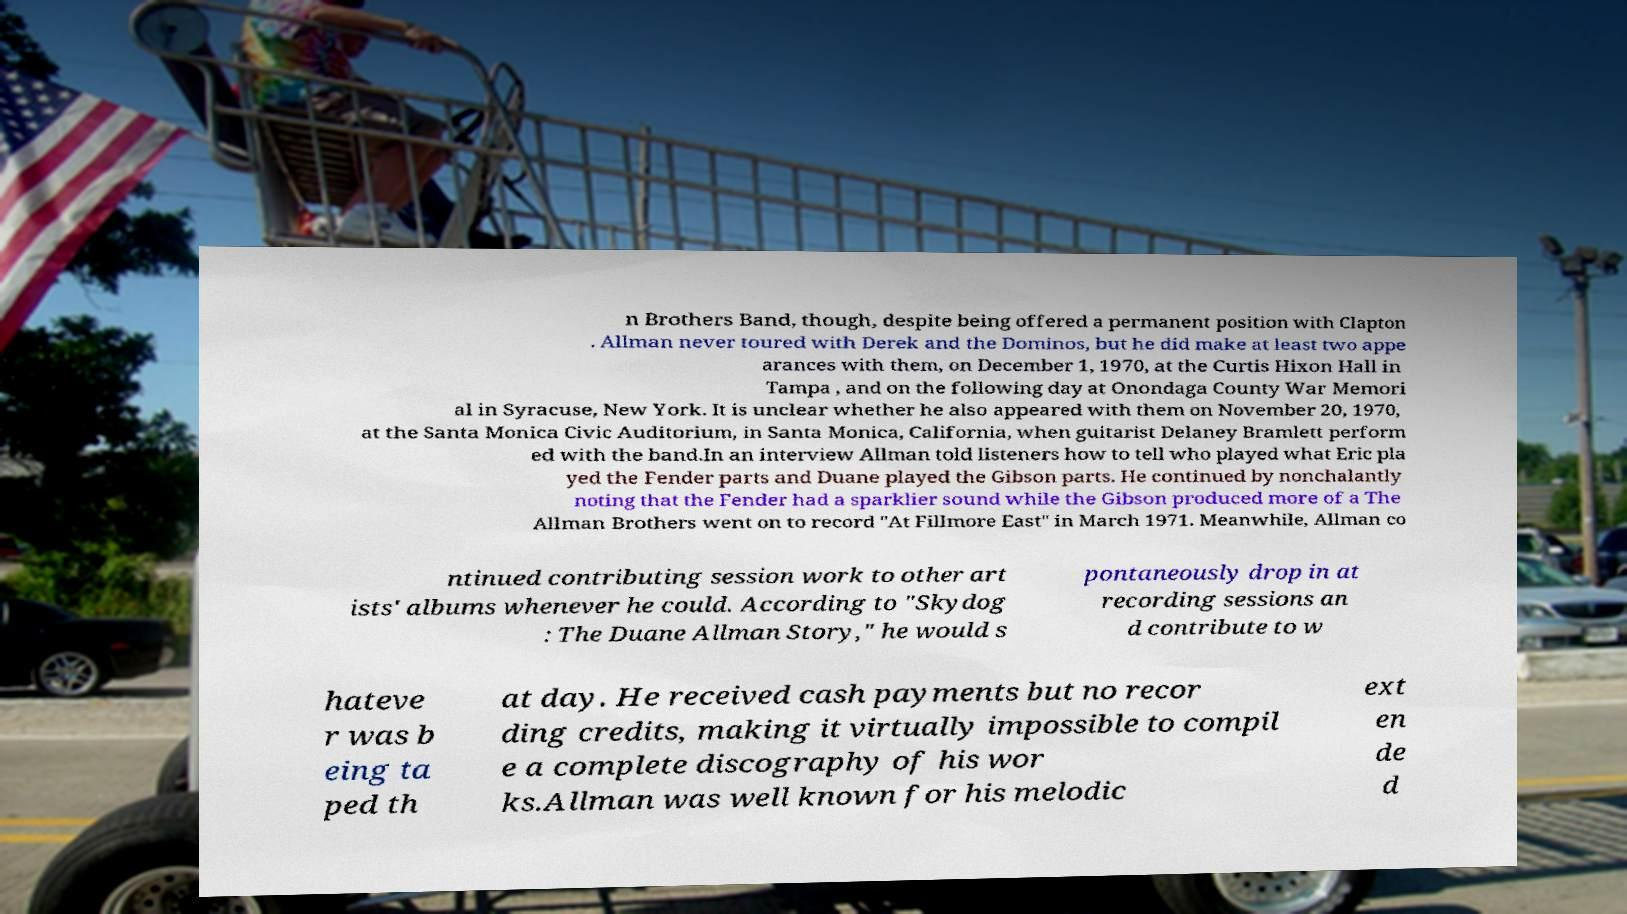For documentation purposes, I need the text within this image transcribed. Could you provide that? n Brothers Band, though, despite being offered a permanent position with Clapton . Allman never toured with Derek and the Dominos, but he did make at least two appe arances with them, on December 1, 1970, at the Curtis Hixon Hall in Tampa , and on the following day at Onondaga County War Memori al in Syracuse, New York. It is unclear whether he also appeared with them on November 20, 1970, at the Santa Monica Civic Auditorium, in Santa Monica, California, when guitarist Delaney Bramlett perform ed with the band.In an interview Allman told listeners how to tell who played what Eric pla yed the Fender parts and Duane played the Gibson parts. He continued by nonchalantly noting that the Fender had a sparklier sound while the Gibson produced more of a The Allman Brothers went on to record "At Fillmore East" in March 1971. Meanwhile, Allman co ntinued contributing session work to other art ists' albums whenever he could. According to "Skydog : The Duane Allman Story," he would s pontaneously drop in at recording sessions an d contribute to w hateve r was b eing ta ped th at day. He received cash payments but no recor ding credits, making it virtually impossible to compil e a complete discography of his wor ks.Allman was well known for his melodic ext en de d 